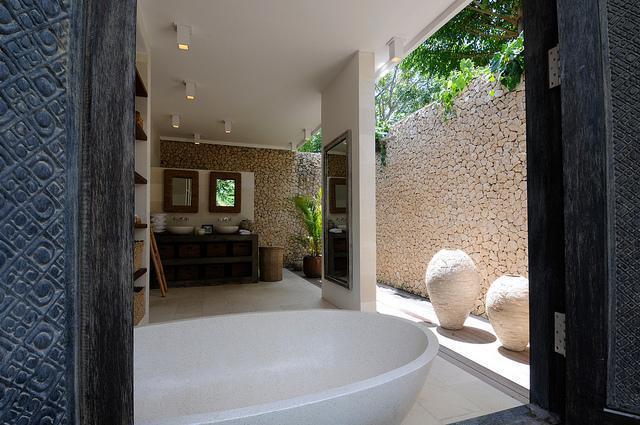How many mirrors are in this picture?
Give a very brief answer. 3. How many vases can you see?
Give a very brief answer. 2. 